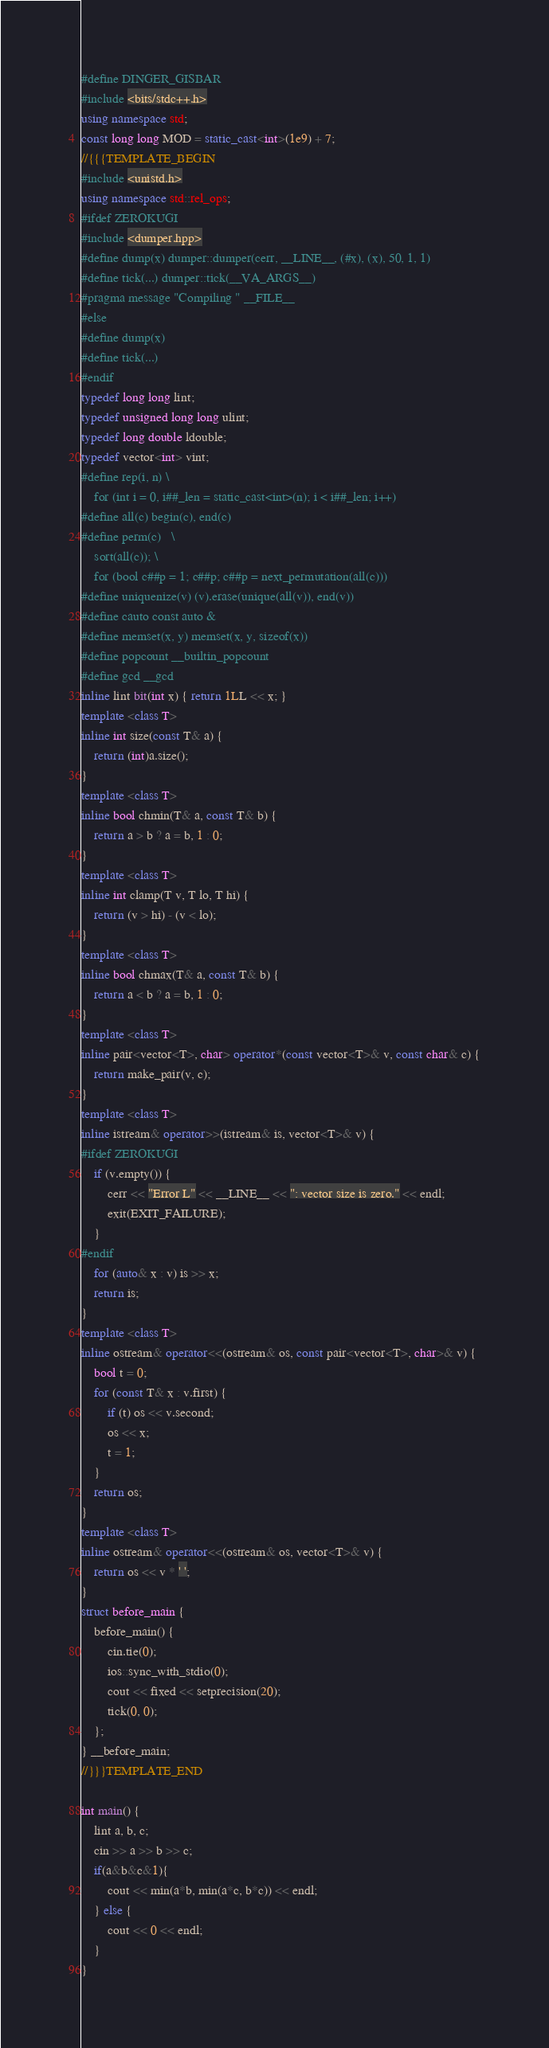<code> <loc_0><loc_0><loc_500><loc_500><_C++_>#define DINGER_GISBAR
#include <bits/stdc++.h>
using namespace std;
const long long MOD = static_cast<int>(1e9) + 7;
//{{{TEMPLATE_BEGIN
#include <unistd.h>
using namespace std::rel_ops;
#ifdef ZEROKUGI
#include <dumper.hpp>
#define dump(x) dumper::dumper(cerr, __LINE__, (#x), (x), 50, 1, 1)
#define tick(...) dumper::tick(__VA_ARGS__)
#pragma message "Compiling " __FILE__
#else
#define dump(x)
#define tick(...)
#endif
typedef long long lint;
typedef unsigned long long ulint;
typedef long double ldouble;
typedef vector<int> vint;
#define rep(i, n) \
    for (int i = 0, i##_len = static_cast<int>(n); i < i##_len; i++)
#define all(c) begin(c), end(c)
#define perm(c)   \
    sort(all(c)); \
    for (bool c##p = 1; c##p; c##p = next_permutation(all(c)))
#define uniquenize(v) (v).erase(unique(all(v)), end(v))
#define cauto const auto &
#define memset(x, y) memset(x, y, sizeof(x))
#define popcount __builtin_popcount
#define gcd __gcd
inline lint bit(int x) { return 1LL << x; }
template <class T>
inline int size(const T& a) {
    return (int)a.size();
}
template <class T>
inline bool chmin(T& a, const T& b) {
    return a > b ? a = b, 1 : 0;
}
template <class T>
inline int clamp(T v, T lo, T hi) {
    return (v > hi) - (v < lo);
}
template <class T>
inline bool chmax(T& a, const T& b) {
    return a < b ? a = b, 1 : 0;
}
template <class T>
inline pair<vector<T>, char> operator*(const vector<T>& v, const char& c) {
    return make_pair(v, c);
}
template <class T>
inline istream& operator>>(istream& is, vector<T>& v) {
#ifdef ZEROKUGI
    if (v.empty()) {
        cerr << "Error L" << __LINE__ << ": vector size is zero." << endl;
        exit(EXIT_FAILURE);
    }
#endif
    for (auto& x : v) is >> x;
    return is;
}
template <class T>
inline ostream& operator<<(ostream& os, const pair<vector<T>, char>& v) {
    bool t = 0;
    for (const T& x : v.first) {
        if (t) os << v.second;
        os << x;
        t = 1;
    }
    return os;
}
template <class T>
inline ostream& operator<<(ostream& os, vector<T>& v) {
    return os << v * ' ';
}
struct before_main {
    before_main() {
        cin.tie(0);
        ios::sync_with_stdio(0);
        cout << fixed << setprecision(20);
        tick(0, 0);
    };
} __before_main;
//}}}TEMPLATE_END

int main() {
    lint a, b, c;
    cin >> a >> b >> c;
    if(a&b&c&1){
        cout << min(a*b, min(a*c, b*c)) << endl;
    } else {
        cout << 0 << endl;
    }
}

</code> 